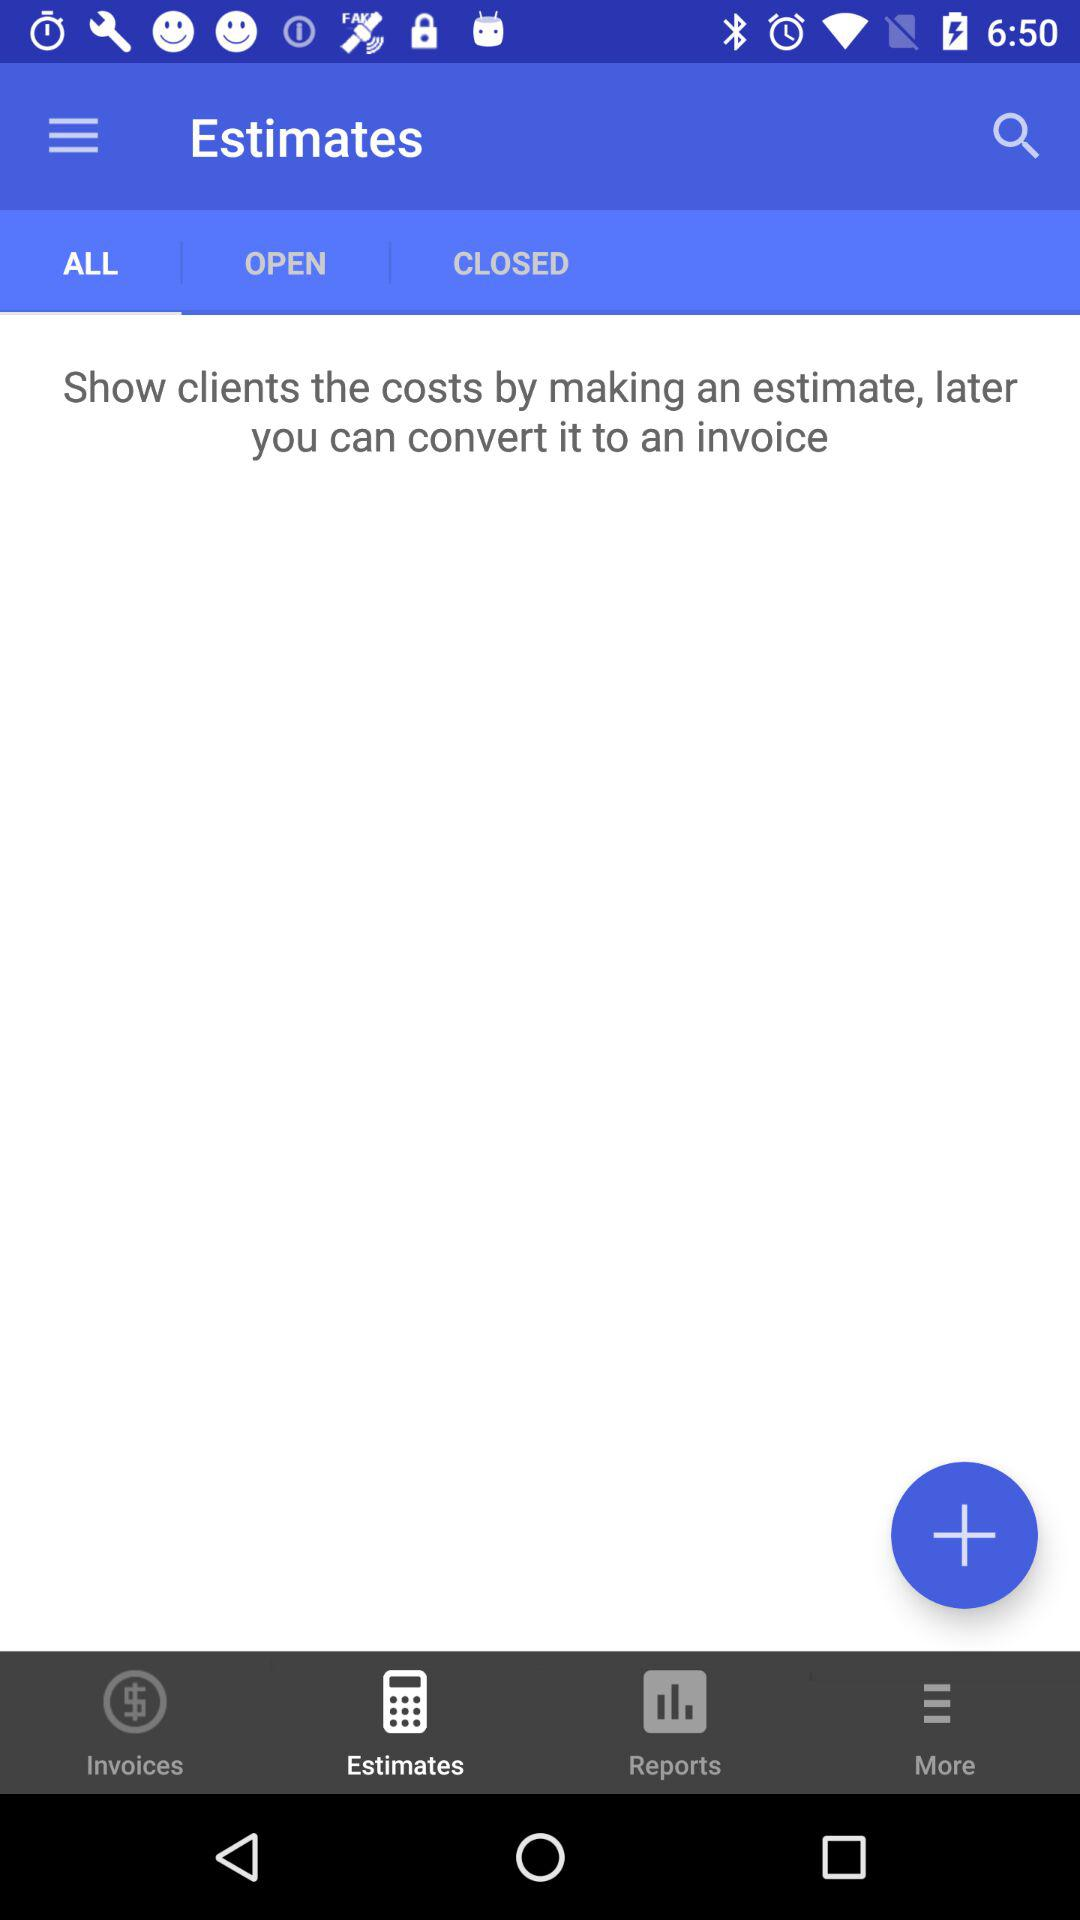What is the selected tab? The selected tab is "ALL". 